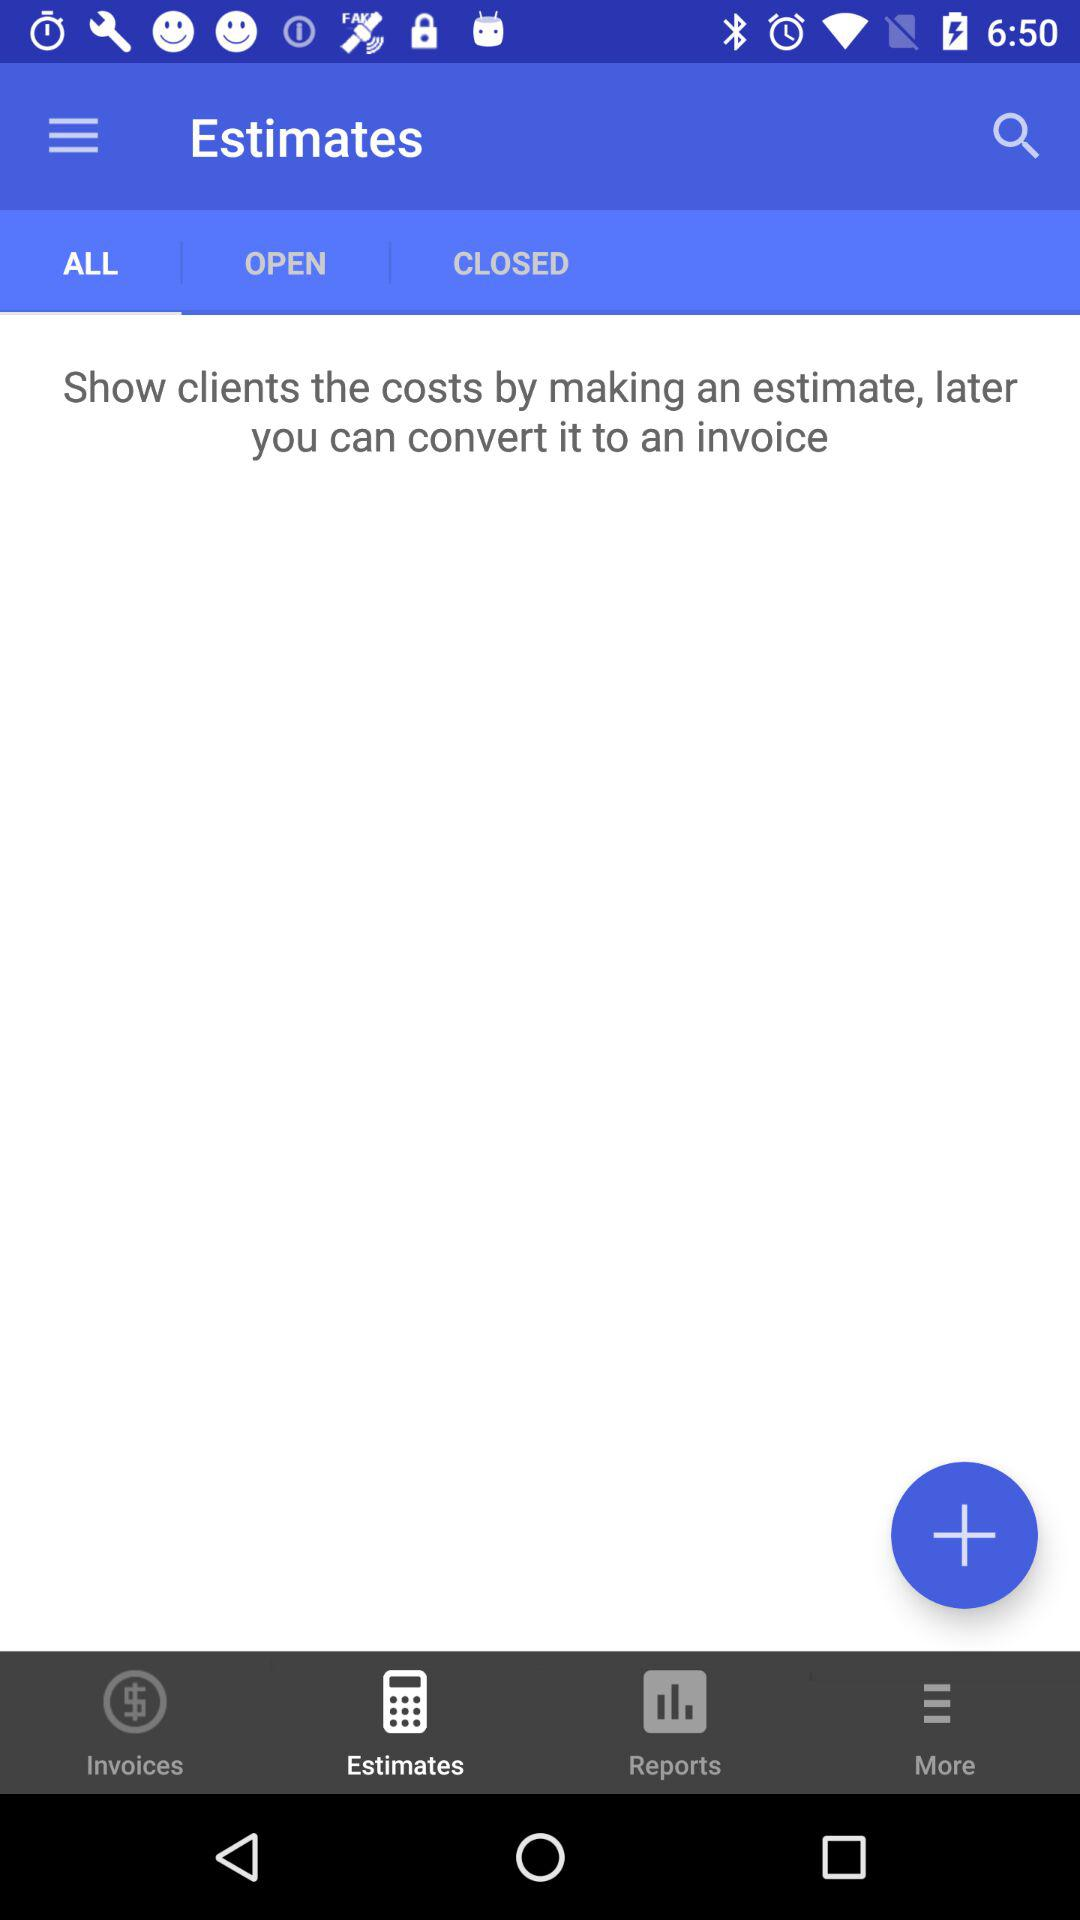What is the selected tab? The selected tab is "ALL". 